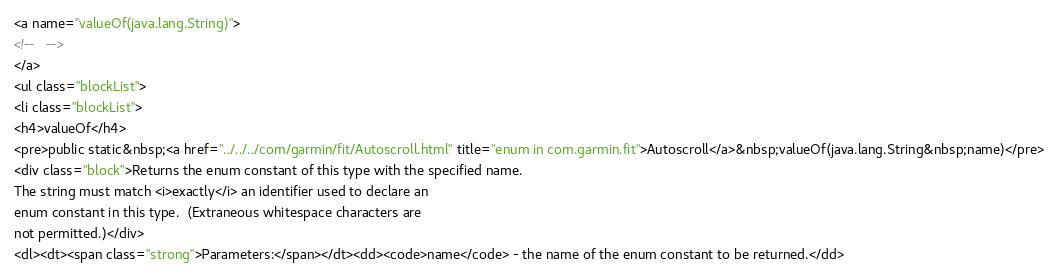Convert code to text. <code><loc_0><loc_0><loc_500><loc_500><_HTML_><a name="valueOf(java.lang.String)">
<!--   -->
</a>
<ul class="blockList">
<li class="blockList">
<h4>valueOf</h4>
<pre>public static&nbsp;<a href="../../../com/garmin/fit/Autoscroll.html" title="enum in com.garmin.fit">Autoscroll</a>&nbsp;valueOf(java.lang.String&nbsp;name)</pre>
<div class="block">Returns the enum constant of this type with the specified name.
The string must match <i>exactly</i> an identifier used to declare an
enum constant in this type.  (Extraneous whitespace characters are 
not permitted.)</div>
<dl><dt><span class="strong">Parameters:</span></dt><dd><code>name</code> - the name of the enum constant to be returned.</dd></code> 